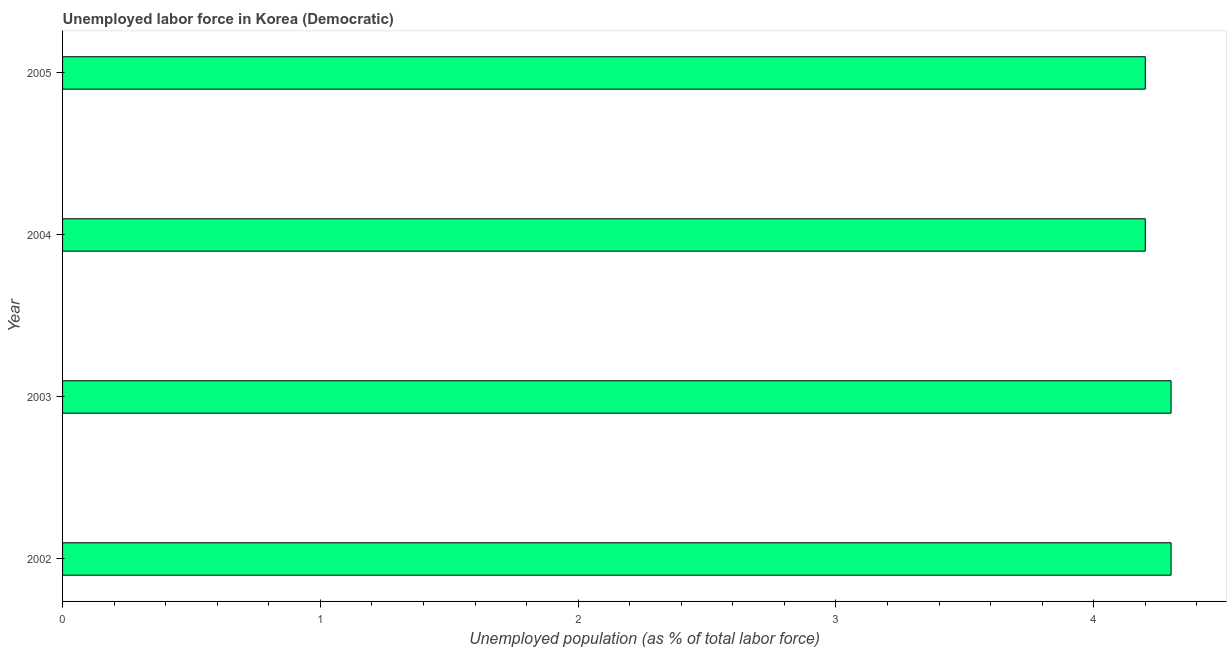What is the title of the graph?
Offer a terse response. Unemployed labor force in Korea (Democratic). What is the label or title of the X-axis?
Give a very brief answer. Unemployed population (as % of total labor force). What is the total unemployed population in 2003?
Your answer should be compact. 4.3. Across all years, what is the maximum total unemployed population?
Make the answer very short. 4.3. Across all years, what is the minimum total unemployed population?
Your answer should be compact. 4.2. In which year was the total unemployed population maximum?
Make the answer very short. 2002. What is the difference between the total unemployed population in 2002 and 2005?
Keep it short and to the point. 0.1. What is the average total unemployed population per year?
Offer a terse response. 4.25. What is the median total unemployed population?
Provide a succinct answer. 4.25. In how many years, is the total unemployed population greater than 2.4 %?
Make the answer very short. 4. Do a majority of the years between 2003 and 2004 (inclusive) have total unemployed population greater than 2.8 %?
Give a very brief answer. Yes. What is the ratio of the total unemployed population in 2002 to that in 2004?
Your response must be concise. 1.02. Is the total unemployed population in 2003 less than that in 2004?
Provide a succinct answer. No. Is the difference between the total unemployed population in 2002 and 2004 greater than the difference between any two years?
Make the answer very short. Yes. What is the difference between the highest and the second highest total unemployed population?
Provide a succinct answer. 0. What is the difference between the highest and the lowest total unemployed population?
Give a very brief answer. 0.1. In how many years, is the total unemployed population greater than the average total unemployed population taken over all years?
Keep it short and to the point. 2. How many bars are there?
Offer a terse response. 4. Are all the bars in the graph horizontal?
Your answer should be compact. Yes. What is the Unemployed population (as % of total labor force) of 2002?
Provide a short and direct response. 4.3. What is the Unemployed population (as % of total labor force) in 2003?
Offer a terse response. 4.3. What is the Unemployed population (as % of total labor force) of 2004?
Make the answer very short. 4.2. What is the Unemployed population (as % of total labor force) in 2005?
Offer a terse response. 4.2. What is the difference between the Unemployed population (as % of total labor force) in 2002 and 2004?
Keep it short and to the point. 0.1. What is the difference between the Unemployed population (as % of total labor force) in 2003 and 2004?
Provide a short and direct response. 0.1. What is the difference between the Unemployed population (as % of total labor force) in 2004 and 2005?
Your answer should be compact. 0. What is the ratio of the Unemployed population (as % of total labor force) in 2002 to that in 2003?
Provide a succinct answer. 1. What is the ratio of the Unemployed population (as % of total labor force) in 2002 to that in 2004?
Offer a terse response. 1.02. What is the ratio of the Unemployed population (as % of total labor force) in 2003 to that in 2005?
Offer a terse response. 1.02. 